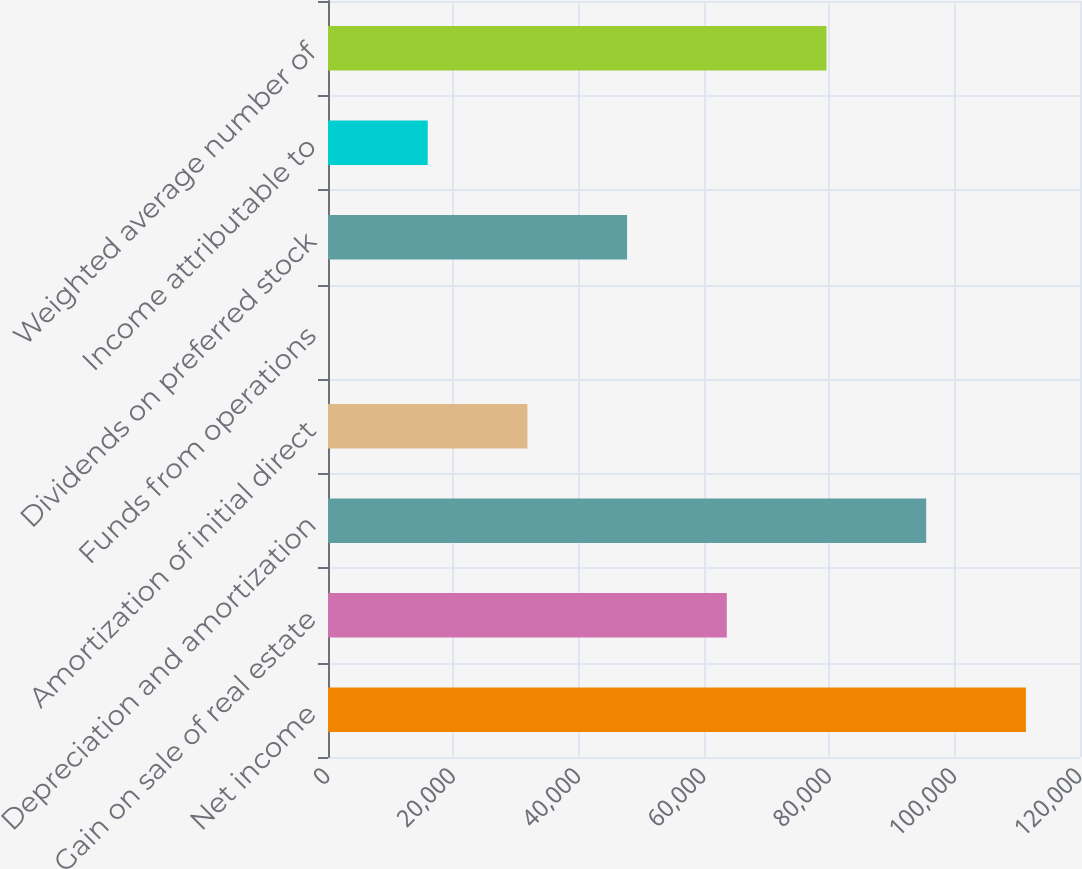Convert chart. <chart><loc_0><loc_0><loc_500><loc_500><bar_chart><fcel>Net income<fcel>Gain on sale of real estate<fcel>Depreciation and amortization<fcel>Amortization of initial direct<fcel>Funds from operations<fcel>Dividends on preferred stock<fcel>Income attributable to<fcel>Weighted average number of<nl><fcel>111365<fcel>63638.1<fcel>95455.7<fcel>31820.5<fcel>2.85<fcel>47729.3<fcel>15911.7<fcel>79546.9<nl></chart> 